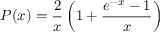<formula> <loc_0><loc_0><loc_500><loc_500>P ( x ) = \frac { 2 } { x } \left ( 1 + \frac { e ^ { - x } - 1 } { x } \right )</formula> 